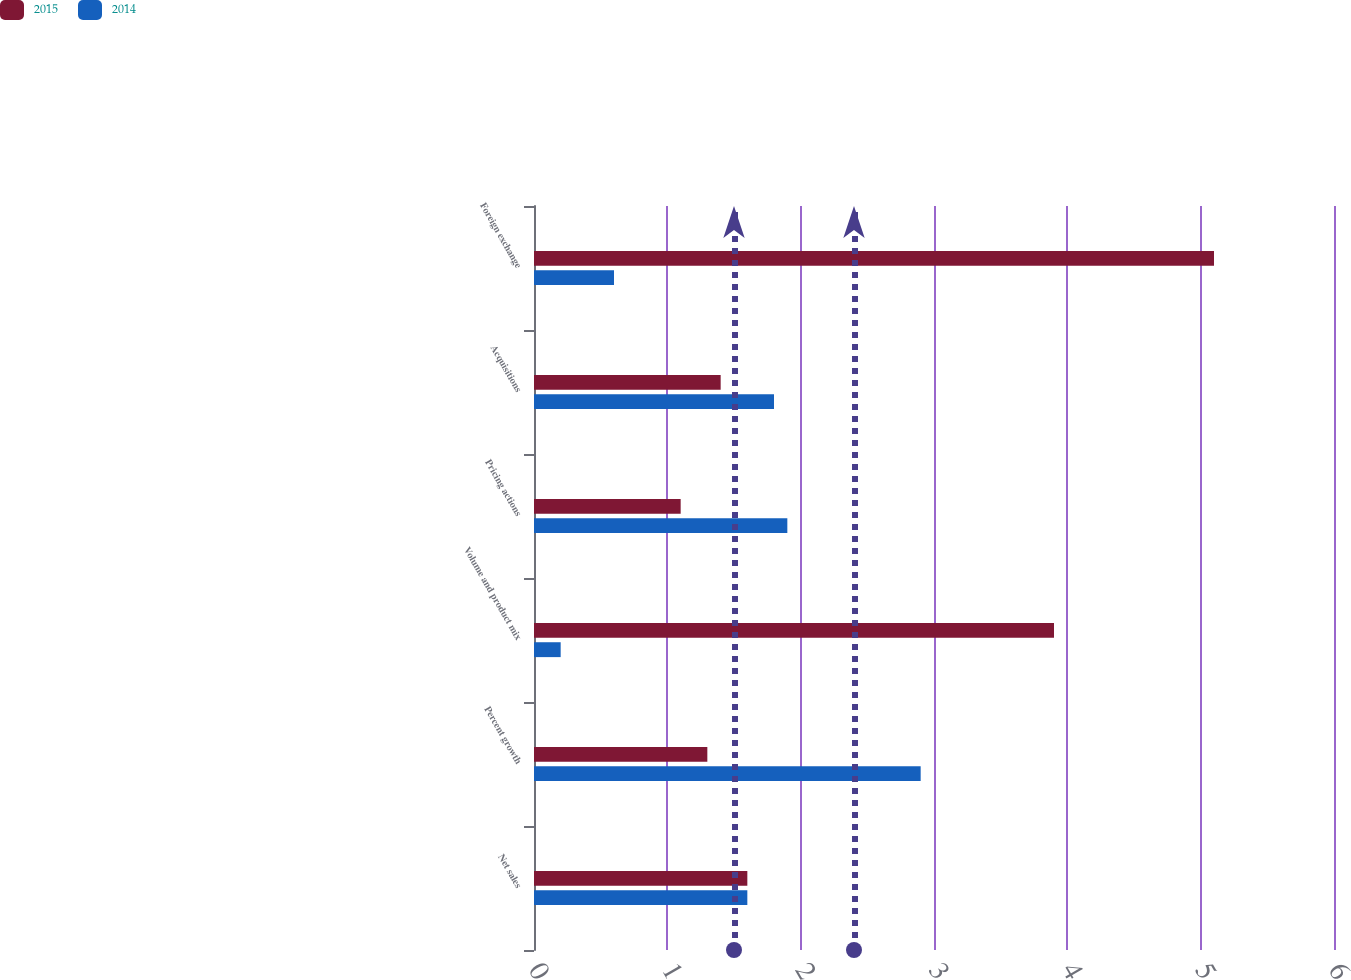Convert chart. <chart><loc_0><loc_0><loc_500><loc_500><stacked_bar_chart><ecel><fcel>Net sales<fcel>Percent growth<fcel>Volume and product mix<fcel>Pricing actions<fcel>Acquisitions<fcel>Foreign exchange<nl><fcel>2015<fcel>1.6<fcel>1.3<fcel>3.9<fcel>1.1<fcel>1.4<fcel>5.1<nl><fcel>2014<fcel>1.6<fcel>2.9<fcel>0.2<fcel>1.9<fcel>1.8<fcel>0.6<nl></chart> 